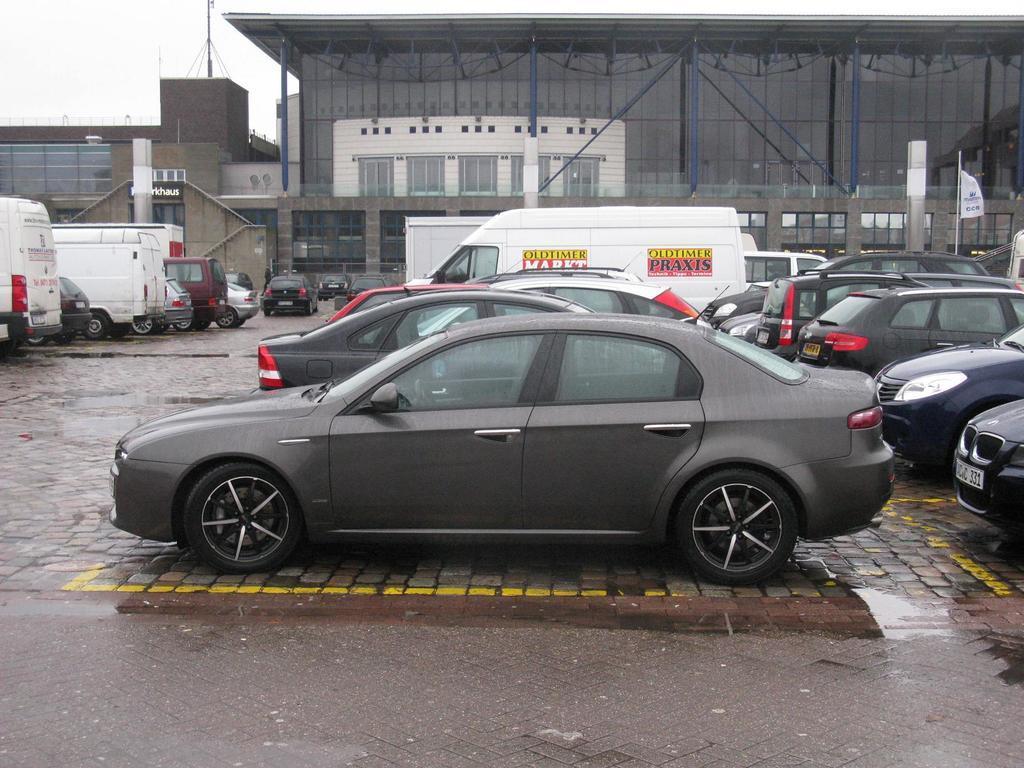Can you describe this image briefly? In this image I can see number of vehicles and on this vehicle I can see something is written. In the background I can see few buildings, few poles and a white colour thing over here. 